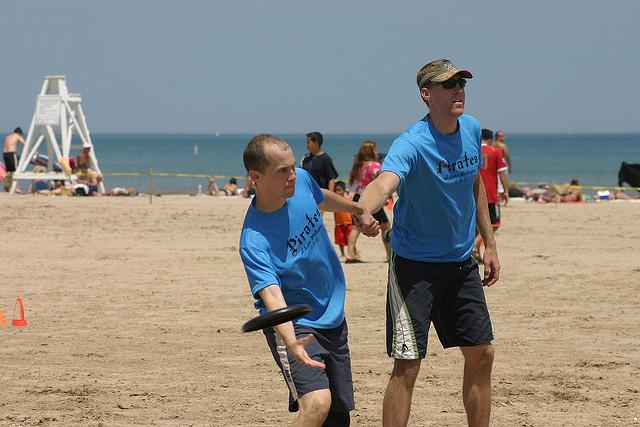Is there a lifeguard?
Short answer required. No. From which hand was the frisbee thrown?
Give a very brief answer. Right. Are the men running?
Quick response, please. No. 